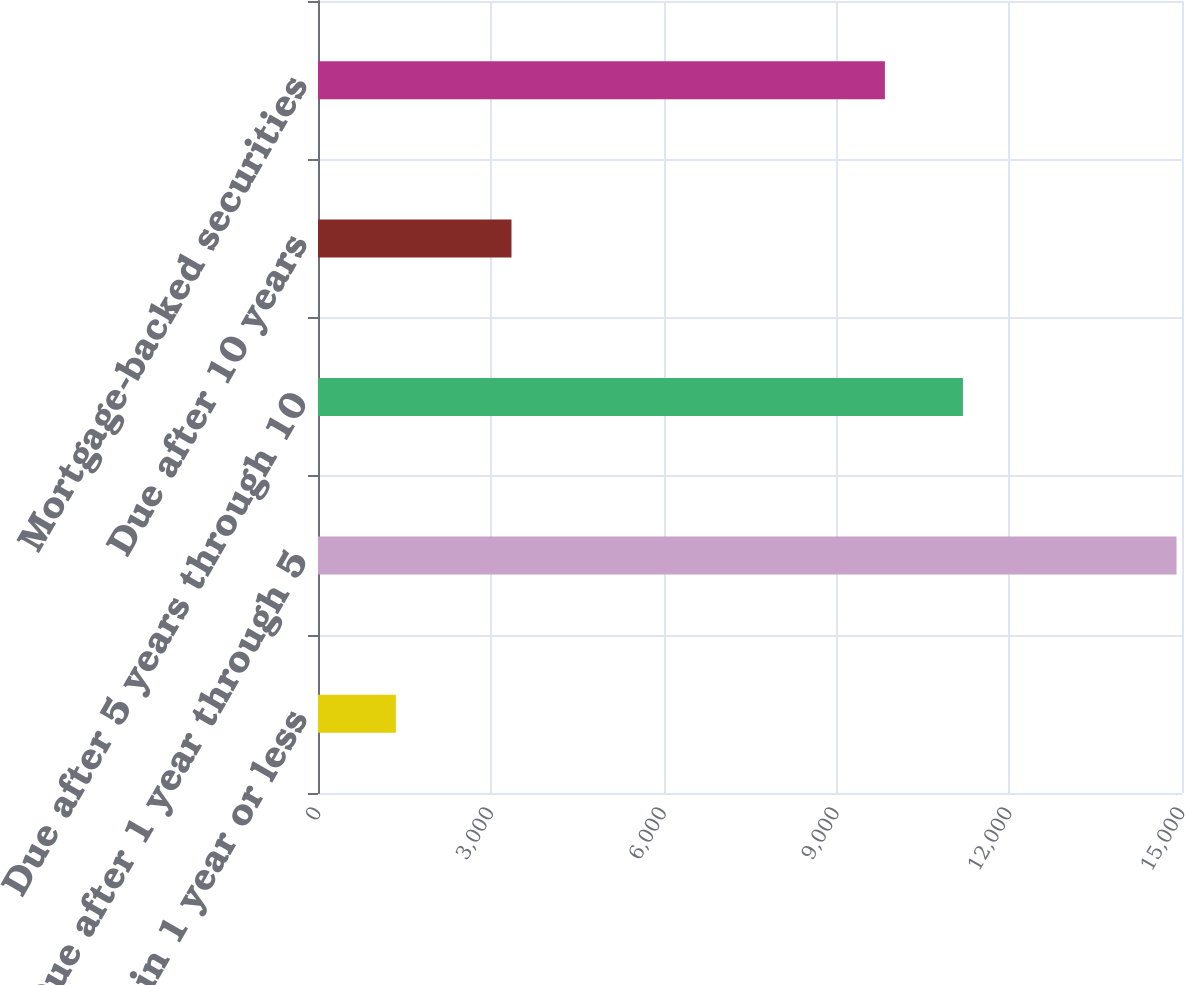<chart> <loc_0><loc_0><loc_500><loc_500><bar_chart><fcel>Due in 1 year or less<fcel>Due after 1 year through 5<fcel>Due after 5 years through 10<fcel>Due after 10 years<fcel>Mortgage-backed securities<nl><fcel>1352<fcel>14905<fcel>11197.3<fcel>3359<fcel>9842<nl></chart> 